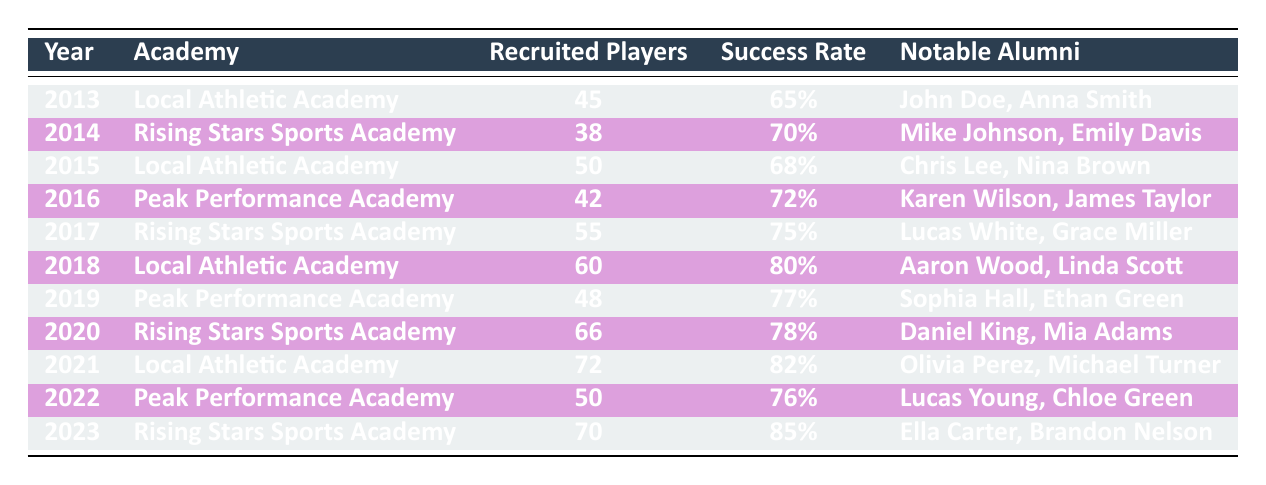What was the success rate of the Local Athletic Academy in 2019? From the table, we can see that in 2019, the Local Athletic Academy had a success rate of 77%.
Answer: 77% Which academy had the highest number of recruited players in 2021? Referring to the table, in 2021, the Local Athletic Academy had the highest number of recruited players, with a total of 72 players.
Answer: Local Athletic Academy What is the average success rate of the Peak Performance Academy over the years? The success rates for Peak Performance Academy are 72% (2016), 77% (2019), and 76% (2022). To calculate the average, we sum these rates: 72 + 77 + 76 = 225, then divide by 3, yielding an average success rate of 75%.
Answer: 75% Did Rising Stars Sports Academy have a success rate below 75% in any year? Looking at the table, the years for Rising Stars Sports Academy and their success rates are: 70% (2014) and 78% (2020), but all other years (2017, 2023) are at or above 75%. Therefore, the answer is yes, they had a rate below 75% in 2014.
Answer: Yes Which academy had the most notable alumni in total over the decade? Counting notable alumni from the table confirms: Local Athletic Academy has 6 notable alumni (2013, 2015, 2018, 2021), Rising Stars Sports Academy has 6 (2014, 2017, 2020, 2023), and Peak Performance Academy has 6 as well (2016, 2019, 2022). Thus, there's a tie between the three academies, each having 6 notable alumni.
Answer: Tie (each has 6) What was the change in the number of recruited players for the Rising Stars Sports Academy from 2014 to 2020? The number of recruited players in 2014 was 38 and in 2020 it rose to 66. To find the change, subtract 38 from 66, which results in an increase of 28 recruited players.
Answer: 28 Was the success rate of Local Athletic Academy consistently increasing every year? Reviewing the success rates from 2013 to 2021, we see: 65%, 68%, 80%, and 82%. The rate did not increase in 2015 (it declined from 68% to 65% in 2013), indicating it was not consistent overall.
Answer: No Which year did the Peak Performance Academy have its lowest success rate? The table indicates that Peak Performance Academy had success rates of 72% (2016), 77% (2019), and 76% (2022). The lowest success rate is 72% in 2016, thus this was their lowest year.
Answer: 2016 